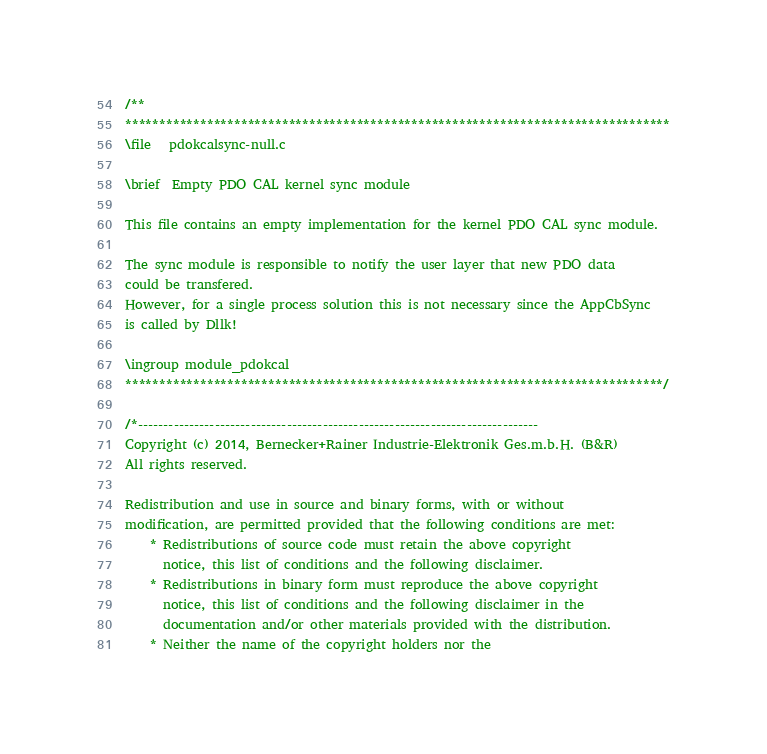Convert code to text. <code><loc_0><loc_0><loc_500><loc_500><_C_>/**
********************************************************************************
\file   pdokcalsync-null.c

\brief  Empty PDO CAL kernel sync module

This file contains an empty implementation for the kernel PDO CAL sync module.

The sync module is responsible to notify the user layer that new PDO data
could be transfered.
However, for a single process solution this is not necessary since the AppCbSync
is called by Dllk!

\ingroup module_pdokcal
*******************************************************************************/

/*------------------------------------------------------------------------------
Copyright (c) 2014, Bernecker+Rainer Industrie-Elektronik Ges.m.b.H. (B&R)
All rights reserved.

Redistribution and use in source and binary forms, with or without
modification, are permitted provided that the following conditions are met:
    * Redistributions of source code must retain the above copyright
      notice, this list of conditions and the following disclaimer.
    * Redistributions in binary form must reproduce the above copyright
      notice, this list of conditions and the following disclaimer in the
      documentation and/or other materials provided with the distribution.
    * Neither the name of the copyright holders nor the</code> 